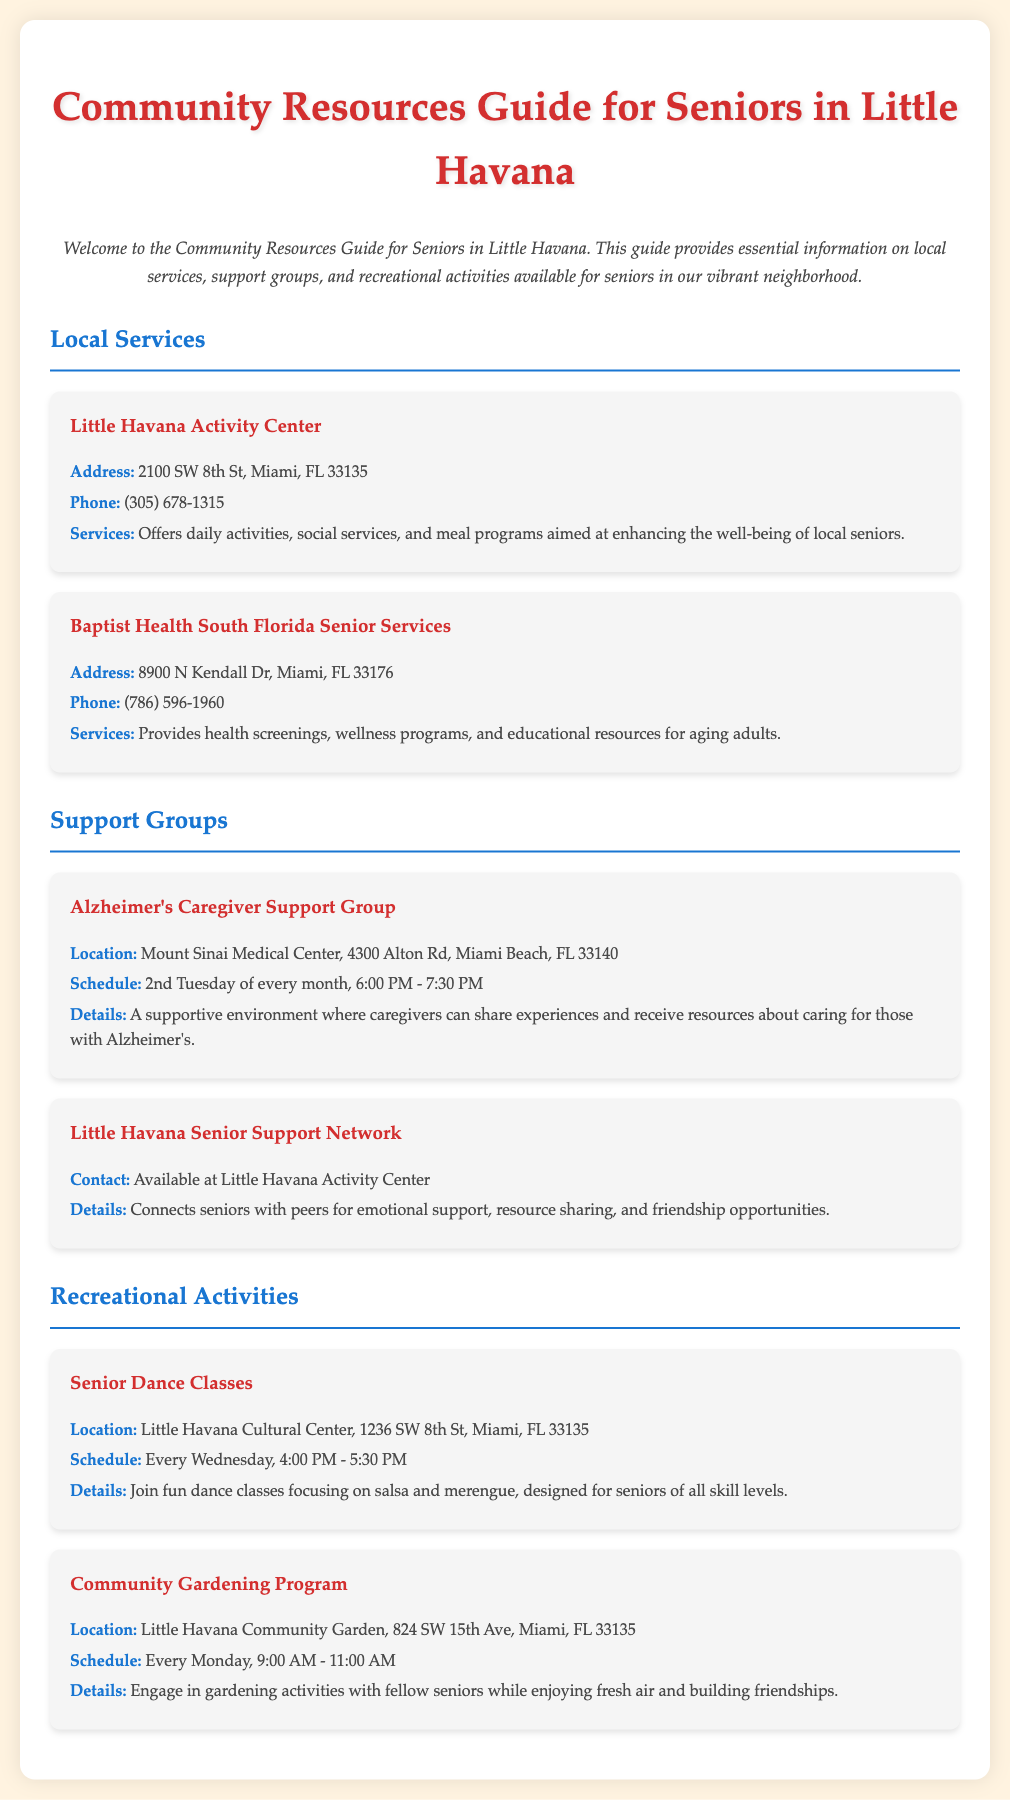What is the address of Little Havana Activity Center? The address is a specific detail mentioned in the document, highlighting the location of the service.
Answer: 2100 SW 8th St, Miami, FL 33135 What phone number can I call for Baptist Health South Florida Senior Services? The phone number is provided as a contact detail for this service in the guide.
Answer: (786) 596-1960 When does the Alzheimer's Caregiver Support Group meet? The schedule indicates the timing of the support group sessions, which is crucial for attendance.
Answer: 2nd Tuesday of every month Where are Senior Dance Classes held? This location is provided to specify where the recreational activity takes place for seniors.
Answer: Little Havana Cultural Center, 1236 SW 8th St, Miami, FL 33135 What type of programs are offered at the Little Havana Activity Center? This question requires reasoning about the various services mentioned in the document.
Answer: Daily activities, social services, and meal programs How often does the Community Gardening Program occur? The frequency of the program is crucial for participation and is stated in the document.
Answer: Every Monday What is the purpose of the Little Havana Senior Support Network? This question explores the main goal of the support network mentioned in the document.
Answer: Emotional support, resource sharing, and friendship opportunities What is the focus of the Senior Dance Classes? This asks for insight into the type of activity available within the recreational category of the document.
Answer: Salsa and merengue 